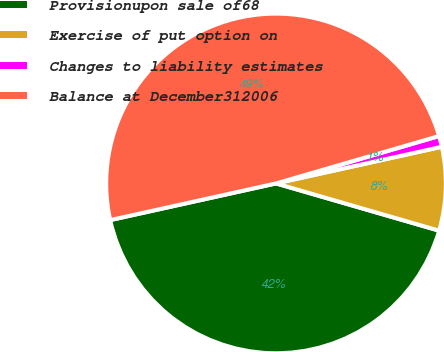Convert chart. <chart><loc_0><loc_0><loc_500><loc_500><pie_chart><fcel>Provisionupon sale of68<fcel>Exercise of put option on<fcel>Changes to liability estimates<fcel>Balance at December312006<nl><fcel>42.05%<fcel>7.95%<fcel>1.04%<fcel>48.96%<nl></chart> 